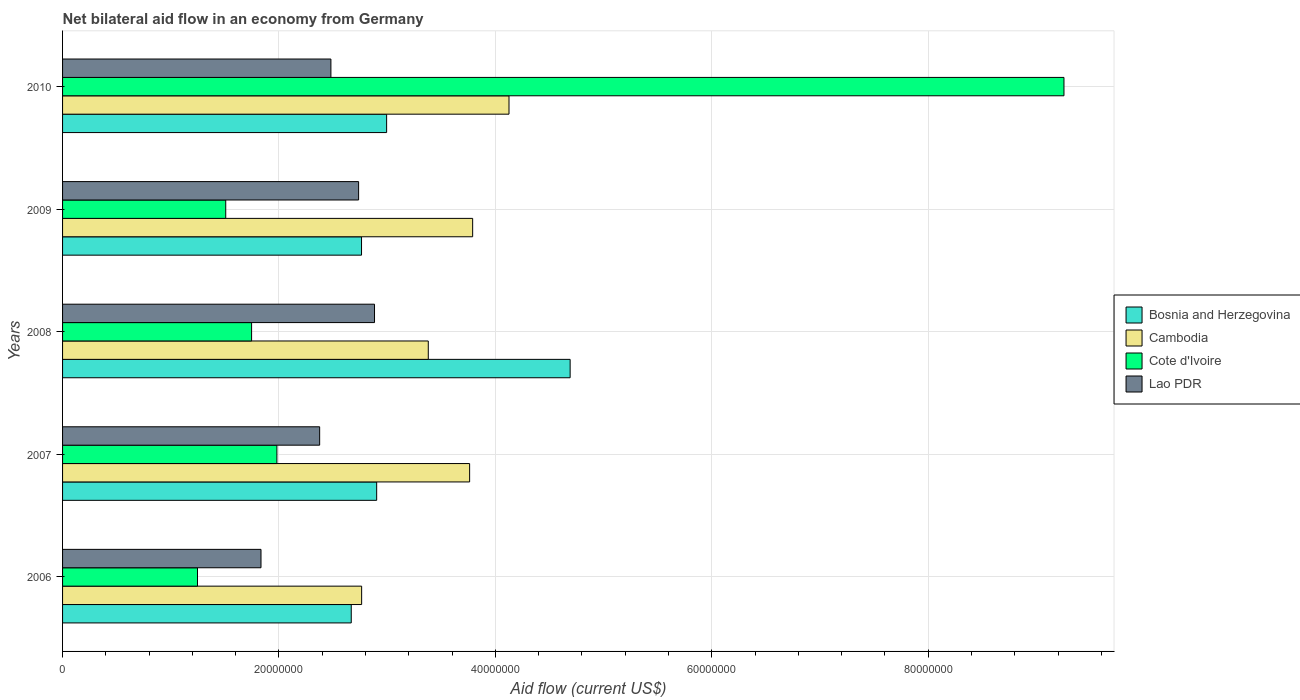Are the number of bars per tick equal to the number of legend labels?
Provide a succinct answer. Yes. Are the number of bars on each tick of the Y-axis equal?
Make the answer very short. Yes. What is the net bilateral aid flow in Cambodia in 2009?
Give a very brief answer. 3.79e+07. Across all years, what is the maximum net bilateral aid flow in Lao PDR?
Give a very brief answer. 2.88e+07. Across all years, what is the minimum net bilateral aid flow in Lao PDR?
Your response must be concise. 1.83e+07. What is the total net bilateral aid flow in Bosnia and Herzegovina in the graph?
Ensure brevity in your answer.  1.60e+08. What is the difference between the net bilateral aid flow in Lao PDR in 2006 and that in 2009?
Your answer should be very brief. -9.02e+06. What is the difference between the net bilateral aid flow in Lao PDR in 2006 and the net bilateral aid flow in Cambodia in 2008?
Make the answer very short. -1.55e+07. What is the average net bilateral aid flow in Cambodia per year?
Make the answer very short. 3.56e+07. In the year 2007, what is the difference between the net bilateral aid flow in Lao PDR and net bilateral aid flow in Bosnia and Herzegovina?
Offer a very short reply. -5.27e+06. What is the ratio of the net bilateral aid flow in Lao PDR in 2006 to that in 2009?
Offer a terse response. 0.67. Is the difference between the net bilateral aid flow in Lao PDR in 2009 and 2010 greater than the difference between the net bilateral aid flow in Bosnia and Herzegovina in 2009 and 2010?
Provide a short and direct response. Yes. What is the difference between the highest and the second highest net bilateral aid flow in Cambodia?
Provide a short and direct response. 3.36e+06. What is the difference between the highest and the lowest net bilateral aid flow in Bosnia and Herzegovina?
Your response must be concise. 2.02e+07. In how many years, is the net bilateral aid flow in Lao PDR greater than the average net bilateral aid flow in Lao PDR taken over all years?
Give a very brief answer. 3. Is the sum of the net bilateral aid flow in Cambodia in 2008 and 2009 greater than the maximum net bilateral aid flow in Lao PDR across all years?
Your answer should be compact. Yes. What does the 3rd bar from the top in 2006 represents?
Provide a succinct answer. Cambodia. What does the 1st bar from the bottom in 2010 represents?
Your response must be concise. Bosnia and Herzegovina. Is it the case that in every year, the sum of the net bilateral aid flow in Lao PDR and net bilateral aid flow in Cambodia is greater than the net bilateral aid flow in Bosnia and Herzegovina?
Ensure brevity in your answer.  Yes. How many bars are there?
Make the answer very short. 20. How many years are there in the graph?
Ensure brevity in your answer.  5. Are the values on the major ticks of X-axis written in scientific E-notation?
Your answer should be very brief. No. How are the legend labels stacked?
Offer a very short reply. Vertical. What is the title of the graph?
Make the answer very short. Net bilateral aid flow in an economy from Germany. Does "Guinea" appear as one of the legend labels in the graph?
Your answer should be very brief. No. What is the label or title of the X-axis?
Provide a short and direct response. Aid flow (current US$). What is the Aid flow (current US$) of Bosnia and Herzegovina in 2006?
Your answer should be compact. 2.67e+07. What is the Aid flow (current US$) of Cambodia in 2006?
Make the answer very short. 2.76e+07. What is the Aid flow (current US$) in Cote d'Ivoire in 2006?
Offer a terse response. 1.25e+07. What is the Aid flow (current US$) of Lao PDR in 2006?
Give a very brief answer. 1.83e+07. What is the Aid flow (current US$) of Bosnia and Herzegovina in 2007?
Your answer should be compact. 2.90e+07. What is the Aid flow (current US$) in Cambodia in 2007?
Your answer should be very brief. 3.76e+07. What is the Aid flow (current US$) of Cote d'Ivoire in 2007?
Your answer should be compact. 1.98e+07. What is the Aid flow (current US$) of Lao PDR in 2007?
Make the answer very short. 2.38e+07. What is the Aid flow (current US$) of Bosnia and Herzegovina in 2008?
Give a very brief answer. 4.69e+07. What is the Aid flow (current US$) of Cambodia in 2008?
Keep it short and to the point. 3.38e+07. What is the Aid flow (current US$) in Cote d'Ivoire in 2008?
Give a very brief answer. 1.75e+07. What is the Aid flow (current US$) in Lao PDR in 2008?
Your answer should be very brief. 2.88e+07. What is the Aid flow (current US$) in Bosnia and Herzegovina in 2009?
Provide a succinct answer. 2.76e+07. What is the Aid flow (current US$) in Cambodia in 2009?
Your response must be concise. 3.79e+07. What is the Aid flow (current US$) in Cote d'Ivoire in 2009?
Keep it short and to the point. 1.51e+07. What is the Aid flow (current US$) in Lao PDR in 2009?
Your answer should be very brief. 2.74e+07. What is the Aid flow (current US$) in Bosnia and Herzegovina in 2010?
Give a very brief answer. 3.00e+07. What is the Aid flow (current US$) of Cambodia in 2010?
Ensure brevity in your answer.  4.13e+07. What is the Aid flow (current US$) of Cote d'Ivoire in 2010?
Make the answer very short. 9.26e+07. What is the Aid flow (current US$) in Lao PDR in 2010?
Your answer should be very brief. 2.48e+07. Across all years, what is the maximum Aid flow (current US$) in Bosnia and Herzegovina?
Offer a very short reply. 4.69e+07. Across all years, what is the maximum Aid flow (current US$) of Cambodia?
Your answer should be compact. 4.13e+07. Across all years, what is the maximum Aid flow (current US$) in Cote d'Ivoire?
Your response must be concise. 9.26e+07. Across all years, what is the maximum Aid flow (current US$) of Lao PDR?
Provide a short and direct response. 2.88e+07. Across all years, what is the minimum Aid flow (current US$) of Bosnia and Herzegovina?
Make the answer very short. 2.67e+07. Across all years, what is the minimum Aid flow (current US$) of Cambodia?
Your response must be concise. 2.76e+07. Across all years, what is the minimum Aid flow (current US$) of Cote d'Ivoire?
Ensure brevity in your answer.  1.25e+07. Across all years, what is the minimum Aid flow (current US$) of Lao PDR?
Make the answer very short. 1.83e+07. What is the total Aid flow (current US$) in Bosnia and Herzegovina in the graph?
Give a very brief answer. 1.60e+08. What is the total Aid flow (current US$) in Cambodia in the graph?
Provide a succinct answer. 1.78e+08. What is the total Aid flow (current US$) in Cote d'Ivoire in the graph?
Offer a very short reply. 1.57e+08. What is the total Aid flow (current US$) in Lao PDR in the graph?
Ensure brevity in your answer.  1.23e+08. What is the difference between the Aid flow (current US$) in Bosnia and Herzegovina in 2006 and that in 2007?
Your answer should be very brief. -2.35e+06. What is the difference between the Aid flow (current US$) in Cambodia in 2006 and that in 2007?
Your answer should be very brief. -9.98e+06. What is the difference between the Aid flow (current US$) in Cote d'Ivoire in 2006 and that in 2007?
Your answer should be very brief. -7.34e+06. What is the difference between the Aid flow (current US$) in Lao PDR in 2006 and that in 2007?
Your response must be concise. -5.42e+06. What is the difference between the Aid flow (current US$) of Bosnia and Herzegovina in 2006 and that in 2008?
Give a very brief answer. -2.02e+07. What is the difference between the Aid flow (current US$) of Cambodia in 2006 and that in 2008?
Your response must be concise. -6.16e+06. What is the difference between the Aid flow (current US$) in Cote d'Ivoire in 2006 and that in 2008?
Your response must be concise. -5.00e+06. What is the difference between the Aid flow (current US$) of Lao PDR in 2006 and that in 2008?
Make the answer very short. -1.05e+07. What is the difference between the Aid flow (current US$) in Bosnia and Herzegovina in 2006 and that in 2009?
Offer a very short reply. -9.50e+05. What is the difference between the Aid flow (current US$) in Cambodia in 2006 and that in 2009?
Your answer should be compact. -1.03e+07. What is the difference between the Aid flow (current US$) of Cote d'Ivoire in 2006 and that in 2009?
Your response must be concise. -2.61e+06. What is the difference between the Aid flow (current US$) of Lao PDR in 2006 and that in 2009?
Keep it short and to the point. -9.02e+06. What is the difference between the Aid flow (current US$) in Bosnia and Herzegovina in 2006 and that in 2010?
Your answer should be compact. -3.27e+06. What is the difference between the Aid flow (current US$) of Cambodia in 2006 and that in 2010?
Offer a terse response. -1.36e+07. What is the difference between the Aid flow (current US$) in Cote d'Ivoire in 2006 and that in 2010?
Offer a terse response. -8.01e+07. What is the difference between the Aid flow (current US$) of Lao PDR in 2006 and that in 2010?
Make the answer very short. -6.46e+06. What is the difference between the Aid flow (current US$) in Bosnia and Herzegovina in 2007 and that in 2008?
Your answer should be compact. -1.79e+07. What is the difference between the Aid flow (current US$) in Cambodia in 2007 and that in 2008?
Ensure brevity in your answer.  3.82e+06. What is the difference between the Aid flow (current US$) of Cote d'Ivoire in 2007 and that in 2008?
Your answer should be compact. 2.34e+06. What is the difference between the Aid flow (current US$) of Lao PDR in 2007 and that in 2008?
Offer a terse response. -5.07e+06. What is the difference between the Aid flow (current US$) in Bosnia and Herzegovina in 2007 and that in 2009?
Provide a short and direct response. 1.40e+06. What is the difference between the Aid flow (current US$) in Cambodia in 2007 and that in 2009?
Give a very brief answer. -2.80e+05. What is the difference between the Aid flow (current US$) of Cote d'Ivoire in 2007 and that in 2009?
Provide a short and direct response. 4.73e+06. What is the difference between the Aid flow (current US$) in Lao PDR in 2007 and that in 2009?
Keep it short and to the point. -3.60e+06. What is the difference between the Aid flow (current US$) in Bosnia and Herzegovina in 2007 and that in 2010?
Your answer should be very brief. -9.20e+05. What is the difference between the Aid flow (current US$) of Cambodia in 2007 and that in 2010?
Provide a short and direct response. -3.64e+06. What is the difference between the Aid flow (current US$) in Cote d'Ivoire in 2007 and that in 2010?
Make the answer very short. -7.27e+07. What is the difference between the Aid flow (current US$) in Lao PDR in 2007 and that in 2010?
Provide a succinct answer. -1.04e+06. What is the difference between the Aid flow (current US$) in Bosnia and Herzegovina in 2008 and that in 2009?
Ensure brevity in your answer.  1.93e+07. What is the difference between the Aid flow (current US$) of Cambodia in 2008 and that in 2009?
Your answer should be compact. -4.10e+06. What is the difference between the Aid flow (current US$) of Cote d'Ivoire in 2008 and that in 2009?
Offer a terse response. 2.39e+06. What is the difference between the Aid flow (current US$) in Lao PDR in 2008 and that in 2009?
Your response must be concise. 1.47e+06. What is the difference between the Aid flow (current US$) in Bosnia and Herzegovina in 2008 and that in 2010?
Provide a short and direct response. 1.70e+07. What is the difference between the Aid flow (current US$) in Cambodia in 2008 and that in 2010?
Your answer should be compact. -7.46e+06. What is the difference between the Aid flow (current US$) in Cote d'Ivoire in 2008 and that in 2010?
Your response must be concise. -7.51e+07. What is the difference between the Aid flow (current US$) of Lao PDR in 2008 and that in 2010?
Your answer should be compact. 4.03e+06. What is the difference between the Aid flow (current US$) of Bosnia and Herzegovina in 2009 and that in 2010?
Your response must be concise. -2.32e+06. What is the difference between the Aid flow (current US$) of Cambodia in 2009 and that in 2010?
Provide a short and direct response. -3.36e+06. What is the difference between the Aid flow (current US$) in Cote d'Ivoire in 2009 and that in 2010?
Make the answer very short. -7.75e+07. What is the difference between the Aid flow (current US$) of Lao PDR in 2009 and that in 2010?
Make the answer very short. 2.56e+06. What is the difference between the Aid flow (current US$) in Bosnia and Herzegovina in 2006 and the Aid flow (current US$) in Cambodia in 2007?
Offer a terse response. -1.09e+07. What is the difference between the Aid flow (current US$) in Bosnia and Herzegovina in 2006 and the Aid flow (current US$) in Cote d'Ivoire in 2007?
Your answer should be compact. 6.87e+06. What is the difference between the Aid flow (current US$) of Bosnia and Herzegovina in 2006 and the Aid flow (current US$) of Lao PDR in 2007?
Offer a very short reply. 2.92e+06. What is the difference between the Aid flow (current US$) in Cambodia in 2006 and the Aid flow (current US$) in Cote d'Ivoire in 2007?
Ensure brevity in your answer.  7.83e+06. What is the difference between the Aid flow (current US$) in Cambodia in 2006 and the Aid flow (current US$) in Lao PDR in 2007?
Provide a succinct answer. 3.88e+06. What is the difference between the Aid flow (current US$) in Cote d'Ivoire in 2006 and the Aid flow (current US$) in Lao PDR in 2007?
Offer a terse response. -1.13e+07. What is the difference between the Aid flow (current US$) in Bosnia and Herzegovina in 2006 and the Aid flow (current US$) in Cambodia in 2008?
Your answer should be compact. -7.12e+06. What is the difference between the Aid flow (current US$) of Bosnia and Herzegovina in 2006 and the Aid flow (current US$) of Cote d'Ivoire in 2008?
Your response must be concise. 9.21e+06. What is the difference between the Aid flow (current US$) in Bosnia and Herzegovina in 2006 and the Aid flow (current US$) in Lao PDR in 2008?
Your response must be concise. -2.15e+06. What is the difference between the Aid flow (current US$) in Cambodia in 2006 and the Aid flow (current US$) in Cote d'Ivoire in 2008?
Provide a short and direct response. 1.02e+07. What is the difference between the Aid flow (current US$) of Cambodia in 2006 and the Aid flow (current US$) of Lao PDR in 2008?
Your response must be concise. -1.19e+06. What is the difference between the Aid flow (current US$) in Cote d'Ivoire in 2006 and the Aid flow (current US$) in Lao PDR in 2008?
Your answer should be very brief. -1.64e+07. What is the difference between the Aid flow (current US$) of Bosnia and Herzegovina in 2006 and the Aid flow (current US$) of Cambodia in 2009?
Offer a terse response. -1.12e+07. What is the difference between the Aid flow (current US$) of Bosnia and Herzegovina in 2006 and the Aid flow (current US$) of Cote d'Ivoire in 2009?
Provide a short and direct response. 1.16e+07. What is the difference between the Aid flow (current US$) of Bosnia and Herzegovina in 2006 and the Aid flow (current US$) of Lao PDR in 2009?
Make the answer very short. -6.80e+05. What is the difference between the Aid flow (current US$) in Cambodia in 2006 and the Aid flow (current US$) in Cote d'Ivoire in 2009?
Offer a terse response. 1.26e+07. What is the difference between the Aid flow (current US$) in Cote d'Ivoire in 2006 and the Aid flow (current US$) in Lao PDR in 2009?
Your answer should be very brief. -1.49e+07. What is the difference between the Aid flow (current US$) of Bosnia and Herzegovina in 2006 and the Aid flow (current US$) of Cambodia in 2010?
Make the answer very short. -1.46e+07. What is the difference between the Aid flow (current US$) in Bosnia and Herzegovina in 2006 and the Aid flow (current US$) in Cote d'Ivoire in 2010?
Your answer should be compact. -6.59e+07. What is the difference between the Aid flow (current US$) of Bosnia and Herzegovina in 2006 and the Aid flow (current US$) of Lao PDR in 2010?
Your response must be concise. 1.88e+06. What is the difference between the Aid flow (current US$) in Cambodia in 2006 and the Aid flow (current US$) in Cote d'Ivoire in 2010?
Ensure brevity in your answer.  -6.49e+07. What is the difference between the Aid flow (current US$) of Cambodia in 2006 and the Aid flow (current US$) of Lao PDR in 2010?
Give a very brief answer. 2.84e+06. What is the difference between the Aid flow (current US$) in Cote d'Ivoire in 2006 and the Aid flow (current US$) in Lao PDR in 2010?
Keep it short and to the point. -1.23e+07. What is the difference between the Aid flow (current US$) in Bosnia and Herzegovina in 2007 and the Aid flow (current US$) in Cambodia in 2008?
Ensure brevity in your answer.  -4.77e+06. What is the difference between the Aid flow (current US$) in Bosnia and Herzegovina in 2007 and the Aid flow (current US$) in Cote d'Ivoire in 2008?
Keep it short and to the point. 1.16e+07. What is the difference between the Aid flow (current US$) of Cambodia in 2007 and the Aid flow (current US$) of Cote d'Ivoire in 2008?
Give a very brief answer. 2.02e+07. What is the difference between the Aid flow (current US$) of Cambodia in 2007 and the Aid flow (current US$) of Lao PDR in 2008?
Your answer should be very brief. 8.79e+06. What is the difference between the Aid flow (current US$) of Cote d'Ivoire in 2007 and the Aid flow (current US$) of Lao PDR in 2008?
Your answer should be very brief. -9.02e+06. What is the difference between the Aid flow (current US$) in Bosnia and Herzegovina in 2007 and the Aid flow (current US$) in Cambodia in 2009?
Give a very brief answer. -8.87e+06. What is the difference between the Aid flow (current US$) in Bosnia and Herzegovina in 2007 and the Aid flow (current US$) in Cote d'Ivoire in 2009?
Give a very brief answer. 1.40e+07. What is the difference between the Aid flow (current US$) of Bosnia and Herzegovina in 2007 and the Aid flow (current US$) of Lao PDR in 2009?
Your response must be concise. 1.67e+06. What is the difference between the Aid flow (current US$) of Cambodia in 2007 and the Aid flow (current US$) of Cote d'Ivoire in 2009?
Give a very brief answer. 2.25e+07. What is the difference between the Aid flow (current US$) of Cambodia in 2007 and the Aid flow (current US$) of Lao PDR in 2009?
Provide a succinct answer. 1.03e+07. What is the difference between the Aid flow (current US$) in Cote d'Ivoire in 2007 and the Aid flow (current US$) in Lao PDR in 2009?
Make the answer very short. -7.55e+06. What is the difference between the Aid flow (current US$) in Bosnia and Herzegovina in 2007 and the Aid flow (current US$) in Cambodia in 2010?
Your answer should be compact. -1.22e+07. What is the difference between the Aid flow (current US$) of Bosnia and Herzegovina in 2007 and the Aid flow (current US$) of Cote d'Ivoire in 2010?
Make the answer very short. -6.35e+07. What is the difference between the Aid flow (current US$) of Bosnia and Herzegovina in 2007 and the Aid flow (current US$) of Lao PDR in 2010?
Ensure brevity in your answer.  4.23e+06. What is the difference between the Aid flow (current US$) of Cambodia in 2007 and the Aid flow (current US$) of Cote d'Ivoire in 2010?
Keep it short and to the point. -5.49e+07. What is the difference between the Aid flow (current US$) of Cambodia in 2007 and the Aid flow (current US$) of Lao PDR in 2010?
Offer a terse response. 1.28e+07. What is the difference between the Aid flow (current US$) of Cote d'Ivoire in 2007 and the Aid flow (current US$) of Lao PDR in 2010?
Keep it short and to the point. -4.99e+06. What is the difference between the Aid flow (current US$) in Bosnia and Herzegovina in 2008 and the Aid flow (current US$) in Cambodia in 2009?
Offer a terse response. 9.01e+06. What is the difference between the Aid flow (current US$) of Bosnia and Herzegovina in 2008 and the Aid flow (current US$) of Cote d'Ivoire in 2009?
Provide a succinct answer. 3.18e+07. What is the difference between the Aid flow (current US$) in Bosnia and Herzegovina in 2008 and the Aid flow (current US$) in Lao PDR in 2009?
Offer a very short reply. 1.96e+07. What is the difference between the Aid flow (current US$) of Cambodia in 2008 and the Aid flow (current US$) of Cote d'Ivoire in 2009?
Keep it short and to the point. 1.87e+07. What is the difference between the Aid flow (current US$) in Cambodia in 2008 and the Aid flow (current US$) in Lao PDR in 2009?
Keep it short and to the point. 6.44e+06. What is the difference between the Aid flow (current US$) in Cote d'Ivoire in 2008 and the Aid flow (current US$) in Lao PDR in 2009?
Offer a very short reply. -9.89e+06. What is the difference between the Aid flow (current US$) in Bosnia and Herzegovina in 2008 and the Aid flow (current US$) in Cambodia in 2010?
Ensure brevity in your answer.  5.65e+06. What is the difference between the Aid flow (current US$) in Bosnia and Herzegovina in 2008 and the Aid flow (current US$) in Cote d'Ivoire in 2010?
Give a very brief answer. -4.56e+07. What is the difference between the Aid flow (current US$) in Bosnia and Herzegovina in 2008 and the Aid flow (current US$) in Lao PDR in 2010?
Provide a short and direct response. 2.21e+07. What is the difference between the Aid flow (current US$) of Cambodia in 2008 and the Aid flow (current US$) of Cote d'Ivoire in 2010?
Offer a terse response. -5.88e+07. What is the difference between the Aid flow (current US$) of Cambodia in 2008 and the Aid flow (current US$) of Lao PDR in 2010?
Offer a very short reply. 9.00e+06. What is the difference between the Aid flow (current US$) of Cote d'Ivoire in 2008 and the Aid flow (current US$) of Lao PDR in 2010?
Ensure brevity in your answer.  -7.33e+06. What is the difference between the Aid flow (current US$) in Bosnia and Herzegovina in 2009 and the Aid flow (current US$) in Cambodia in 2010?
Offer a terse response. -1.36e+07. What is the difference between the Aid flow (current US$) in Bosnia and Herzegovina in 2009 and the Aid flow (current US$) in Cote d'Ivoire in 2010?
Your answer should be compact. -6.49e+07. What is the difference between the Aid flow (current US$) of Bosnia and Herzegovina in 2009 and the Aid flow (current US$) of Lao PDR in 2010?
Your response must be concise. 2.83e+06. What is the difference between the Aid flow (current US$) of Cambodia in 2009 and the Aid flow (current US$) of Cote d'Ivoire in 2010?
Your answer should be very brief. -5.46e+07. What is the difference between the Aid flow (current US$) of Cambodia in 2009 and the Aid flow (current US$) of Lao PDR in 2010?
Give a very brief answer. 1.31e+07. What is the difference between the Aid flow (current US$) in Cote d'Ivoire in 2009 and the Aid flow (current US$) in Lao PDR in 2010?
Your answer should be compact. -9.72e+06. What is the average Aid flow (current US$) in Bosnia and Herzegovina per year?
Ensure brevity in your answer.  3.20e+07. What is the average Aid flow (current US$) of Cambodia per year?
Your response must be concise. 3.56e+07. What is the average Aid flow (current US$) of Cote d'Ivoire per year?
Offer a very short reply. 3.15e+07. What is the average Aid flow (current US$) in Lao PDR per year?
Your response must be concise. 2.46e+07. In the year 2006, what is the difference between the Aid flow (current US$) of Bosnia and Herzegovina and Aid flow (current US$) of Cambodia?
Ensure brevity in your answer.  -9.60e+05. In the year 2006, what is the difference between the Aid flow (current US$) of Bosnia and Herzegovina and Aid flow (current US$) of Cote d'Ivoire?
Provide a succinct answer. 1.42e+07. In the year 2006, what is the difference between the Aid flow (current US$) in Bosnia and Herzegovina and Aid flow (current US$) in Lao PDR?
Give a very brief answer. 8.34e+06. In the year 2006, what is the difference between the Aid flow (current US$) in Cambodia and Aid flow (current US$) in Cote d'Ivoire?
Give a very brief answer. 1.52e+07. In the year 2006, what is the difference between the Aid flow (current US$) in Cambodia and Aid flow (current US$) in Lao PDR?
Your response must be concise. 9.30e+06. In the year 2006, what is the difference between the Aid flow (current US$) of Cote d'Ivoire and Aid flow (current US$) of Lao PDR?
Your answer should be compact. -5.87e+06. In the year 2007, what is the difference between the Aid flow (current US$) of Bosnia and Herzegovina and Aid flow (current US$) of Cambodia?
Your response must be concise. -8.59e+06. In the year 2007, what is the difference between the Aid flow (current US$) of Bosnia and Herzegovina and Aid flow (current US$) of Cote d'Ivoire?
Make the answer very short. 9.22e+06. In the year 2007, what is the difference between the Aid flow (current US$) of Bosnia and Herzegovina and Aid flow (current US$) of Lao PDR?
Your answer should be compact. 5.27e+06. In the year 2007, what is the difference between the Aid flow (current US$) of Cambodia and Aid flow (current US$) of Cote d'Ivoire?
Your answer should be compact. 1.78e+07. In the year 2007, what is the difference between the Aid flow (current US$) of Cambodia and Aid flow (current US$) of Lao PDR?
Provide a short and direct response. 1.39e+07. In the year 2007, what is the difference between the Aid flow (current US$) of Cote d'Ivoire and Aid flow (current US$) of Lao PDR?
Your answer should be very brief. -3.95e+06. In the year 2008, what is the difference between the Aid flow (current US$) of Bosnia and Herzegovina and Aid flow (current US$) of Cambodia?
Provide a succinct answer. 1.31e+07. In the year 2008, what is the difference between the Aid flow (current US$) of Bosnia and Herzegovina and Aid flow (current US$) of Cote d'Ivoire?
Your answer should be very brief. 2.94e+07. In the year 2008, what is the difference between the Aid flow (current US$) in Bosnia and Herzegovina and Aid flow (current US$) in Lao PDR?
Give a very brief answer. 1.81e+07. In the year 2008, what is the difference between the Aid flow (current US$) of Cambodia and Aid flow (current US$) of Cote d'Ivoire?
Your answer should be compact. 1.63e+07. In the year 2008, what is the difference between the Aid flow (current US$) of Cambodia and Aid flow (current US$) of Lao PDR?
Offer a terse response. 4.97e+06. In the year 2008, what is the difference between the Aid flow (current US$) of Cote d'Ivoire and Aid flow (current US$) of Lao PDR?
Make the answer very short. -1.14e+07. In the year 2009, what is the difference between the Aid flow (current US$) in Bosnia and Herzegovina and Aid flow (current US$) in Cambodia?
Your answer should be very brief. -1.03e+07. In the year 2009, what is the difference between the Aid flow (current US$) in Bosnia and Herzegovina and Aid flow (current US$) in Cote d'Ivoire?
Give a very brief answer. 1.26e+07. In the year 2009, what is the difference between the Aid flow (current US$) of Cambodia and Aid flow (current US$) of Cote d'Ivoire?
Make the answer very short. 2.28e+07. In the year 2009, what is the difference between the Aid flow (current US$) in Cambodia and Aid flow (current US$) in Lao PDR?
Offer a very short reply. 1.05e+07. In the year 2009, what is the difference between the Aid flow (current US$) of Cote d'Ivoire and Aid flow (current US$) of Lao PDR?
Your answer should be compact. -1.23e+07. In the year 2010, what is the difference between the Aid flow (current US$) of Bosnia and Herzegovina and Aid flow (current US$) of Cambodia?
Give a very brief answer. -1.13e+07. In the year 2010, what is the difference between the Aid flow (current US$) in Bosnia and Herzegovina and Aid flow (current US$) in Cote d'Ivoire?
Your response must be concise. -6.26e+07. In the year 2010, what is the difference between the Aid flow (current US$) in Bosnia and Herzegovina and Aid flow (current US$) in Lao PDR?
Your answer should be very brief. 5.15e+06. In the year 2010, what is the difference between the Aid flow (current US$) in Cambodia and Aid flow (current US$) in Cote d'Ivoire?
Give a very brief answer. -5.13e+07. In the year 2010, what is the difference between the Aid flow (current US$) in Cambodia and Aid flow (current US$) in Lao PDR?
Offer a very short reply. 1.65e+07. In the year 2010, what is the difference between the Aid flow (current US$) in Cote d'Ivoire and Aid flow (current US$) in Lao PDR?
Make the answer very short. 6.78e+07. What is the ratio of the Aid flow (current US$) of Bosnia and Herzegovina in 2006 to that in 2007?
Your answer should be very brief. 0.92. What is the ratio of the Aid flow (current US$) of Cambodia in 2006 to that in 2007?
Your answer should be very brief. 0.73. What is the ratio of the Aid flow (current US$) of Cote d'Ivoire in 2006 to that in 2007?
Ensure brevity in your answer.  0.63. What is the ratio of the Aid flow (current US$) of Lao PDR in 2006 to that in 2007?
Ensure brevity in your answer.  0.77. What is the ratio of the Aid flow (current US$) of Bosnia and Herzegovina in 2006 to that in 2008?
Your answer should be compact. 0.57. What is the ratio of the Aid flow (current US$) in Cambodia in 2006 to that in 2008?
Keep it short and to the point. 0.82. What is the ratio of the Aid flow (current US$) of Cote d'Ivoire in 2006 to that in 2008?
Offer a terse response. 0.71. What is the ratio of the Aid flow (current US$) in Lao PDR in 2006 to that in 2008?
Offer a very short reply. 0.64. What is the ratio of the Aid flow (current US$) in Bosnia and Herzegovina in 2006 to that in 2009?
Ensure brevity in your answer.  0.97. What is the ratio of the Aid flow (current US$) in Cambodia in 2006 to that in 2009?
Provide a succinct answer. 0.73. What is the ratio of the Aid flow (current US$) of Cote d'Ivoire in 2006 to that in 2009?
Your response must be concise. 0.83. What is the ratio of the Aid flow (current US$) in Lao PDR in 2006 to that in 2009?
Offer a terse response. 0.67. What is the ratio of the Aid flow (current US$) in Bosnia and Herzegovina in 2006 to that in 2010?
Make the answer very short. 0.89. What is the ratio of the Aid flow (current US$) of Cambodia in 2006 to that in 2010?
Keep it short and to the point. 0.67. What is the ratio of the Aid flow (current US$) in Cote d'Ivoire in 2006 to that in 2010?
Provide a short and direct response. 0.13. What is the ratio of the Aid flow (current US$) of Lao PDR in 2006 to that in 2010?
Offer a terse response. 0.74. What is the ratio of the Aid flow (current US$) in Bosnia and Herzegovina in 2007 to that in 2008?
Offer a very short reply. 0.62. What is the ratio of the Aid flow (current US$) in Cambodia in 2007 to that in 2008?
Ensure brevity in your answer.  1.11. What is the ratio of the Aid flow (current US$) in Cote d'Ivoire in 2007 to that in 2008?
Make the answer very short. 1.13. What is the ratio of the Aid flow (current US$) in Lao PDR in 2007 to that in 2008?
Provide a succinct answer. 0.82. What is the ratio of the Aid flow (current US$) of Bosnia and Herzegovina in 2007 to that in 2009?
Ensure brevity in your answer.  1.05. What is the ratio of the Aid flow (current US$) of Cambodia in 2007 to that in 2009?
Your response must be concise. 0.99. What is the ratio of the Aid flow (current US$) of Cote d'Ivoire in 2007 to that in 2009?
Make the answer very short. 1.31. What is the ratio of the Aid flow (current US$) of Lao PDR in 2007 to that in 2009?
Your response must be concise. 0.87. What is the ratio of the Aid flow (current US$) in Bosnia and Herzegovina in 2007 to that in 2010?
Offer a very short reply. 0.97. What is the ratio of the Aid flow (current US$) of Cambodia in 2007 to that in 2010?
Your response must be concise. 0.91. What is the ratio of the Aid flow (current US$) of Cote d'Ivoire in 2007 to that in 2010?
Make the answer very short. 0.21. What is the ratio of the Aid flow (current US$) in Lao PDR in 2007 to that in 2010?
Keep it short and to the point. 0.96. What is the ratio of the Aid flow (current US$) in Bosnia and Herzegovina in 2008 to that in 2009?
Ensure brevity in your answer.  1.7. What is the ratio of the Aid flow (current US$) in Cambodia in 2008 to that in 2009?
Your response must be concise. 0.89. What is the ratio of the Aid flow (current US$) of Cote d'Ivoire in 2008 to that in 2009?
Ensure brevity in your answer.  1.16. What is the ratio of the Aid flow (current US$) of Lao PDR in 2008 to that in 2009?
Your response must be concise. 1.05. What is the ratio of the Aid flow (current US$) of Bosnia and Herzegovina in 2008 to that in 2010?
Ensure brevity in your answer.  1.57. What is the ratio of the Aid flow (current US$) in Cambodia in 2008 to that in 2010?
Offer a very short reply. 0.82. What is the ratio of the Aid flow (current US$) of Cote d'Ivoire in 2008 to that in 2010?
Your answer should be very brief. 0.19. What is the ratio of the Aid flow (current US$) of Lao PDR in 2008 to that in 2010?
Your response must be concise. 1.16. What is the ratio of the Aid flow (current US$) in Bosnia and Herzegovina in 2009 to that in 2010?
Your response must be concise. 0.92. What is the ratio of the Aid flow (current US$) in Cambodia in 2009 to that in 2010?
Make the answer very short. 0.92. What is the ratio of the Aid flow (current US$) of Cote d'Ivoire in 2009 to that in 2010?
Offer a terse response. 0.16. What is the ratio of the Aid flow (current US$) of Lao PDR in 2009 to that in 2010?
Provide a succinct answer. 1.1. What is the difference between the highest and the second highest Aid flow (current US$) of Bosnia and Herzegovina?
Keep it short and to the point. 1.70e+07. What is the difference between the highest and the second highest Aid flow (current US$) in Cambodia?
Your response must be concise. 3.36e+06. What is the difference between the highest and the second highest Aid flow (current US$) in Cote d'Ivoire?
Your response must be concise. 7.27e+07. What is the difference between the highest and the second highest Aid flow (current US$) of Lao PDR?
Your response must be concise. 1.47e+06. What is the difference between the highest and the lowest Aid flow (current US$) of Bosnia and Herzegovina?
Make the answer very short. 2.02e+07. What is the difference between the highest and the lowest Aid flow (current US$) of Cambodia?
Make the answer very short. 1.36e+07. What is the difference between the highest and the lowest Aid flow (current US$) of Cote d'Ivoire?
Your answer should be very brief. 8.01e+07. What is the difference between the highest and the lowest Aid flow (current US$) in Lao PDR?
Your response must be concise. 1.05e+07. 